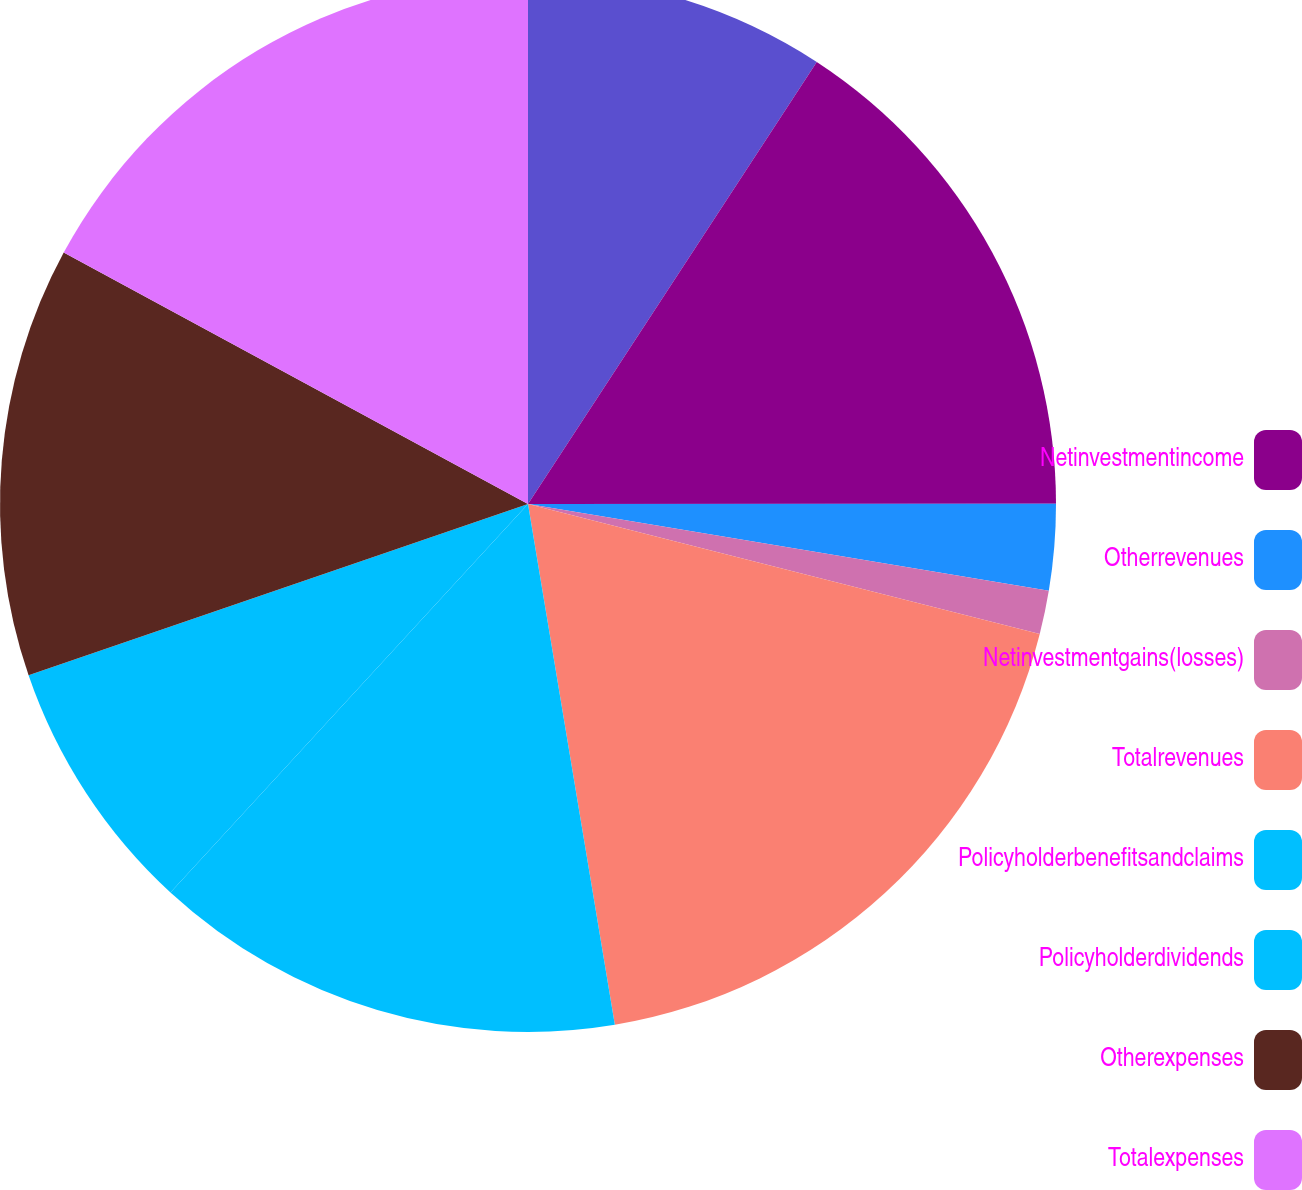<chart> <loc_0><loc_0><loc_500><loc_500><pie_chart><ecel><fcel>Netinvestmentincome<fcel>Otherrevenues<fcel>Netinvestmentgains(losses)<fcel>Totalrevenues<fcel>Policyholderbenefitsandclaims<fcel>Policyholderdividends<fcel>Otherexpenses<fcel>Totalexpenses<nl><fcel>9.21%<fcel>15.78%<fcel>2.64%<fcel>1.33%<fcel>18.41%<fcel>14.47%<fcel>7.9%<fcel>13.16%<fcel>17.1%<nl></chart> 